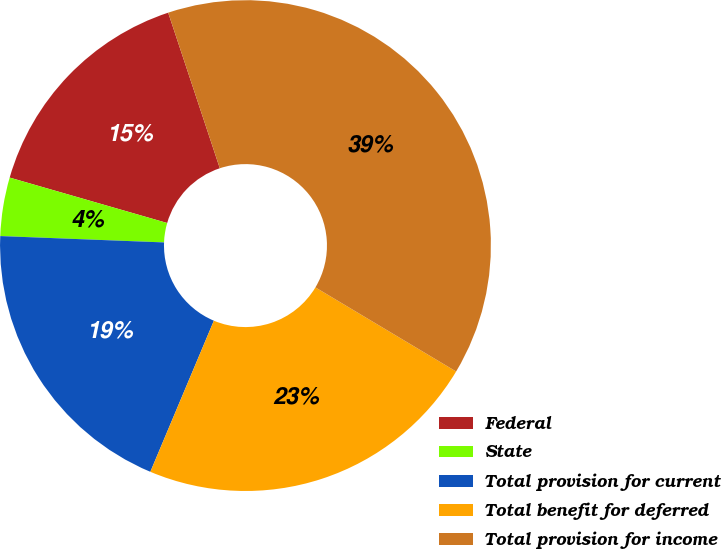<chart> <loc_0><loc_0><loc_500><loc_500><pie_chart><fcel>Federal<fcel>State<fcel>Total provision for current<fcel>Total benefit for deferred<fcel>Total provision for income<nl><fcel>15.43%<fcel>3.85%<fcel>19.28%<fcel>22.76%<fcel>38.67%<nl></chart> 